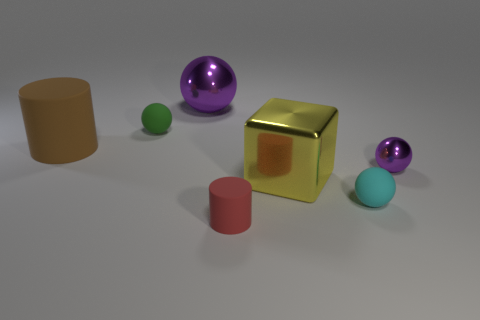Subtract all small green matte balls. How many balls are left? 3 Add 2 purple things. How many objects exist? 9 Subtract all brown spheres. Subtract all yellow blocks. How many spheres are left? 4 Subtract all cylinders. How many objects are left? 5 Subtract 1 red cylinders. How many objects are left? 6 Subtract all purple metal spheres. Subtract all big brown matte cylinders. How many objects are left? 4 Add 7 big rubber cylinders. How many big rubber cylinders are left? 8 Add 7 large cylinders. How many large cylinders exist? 8 